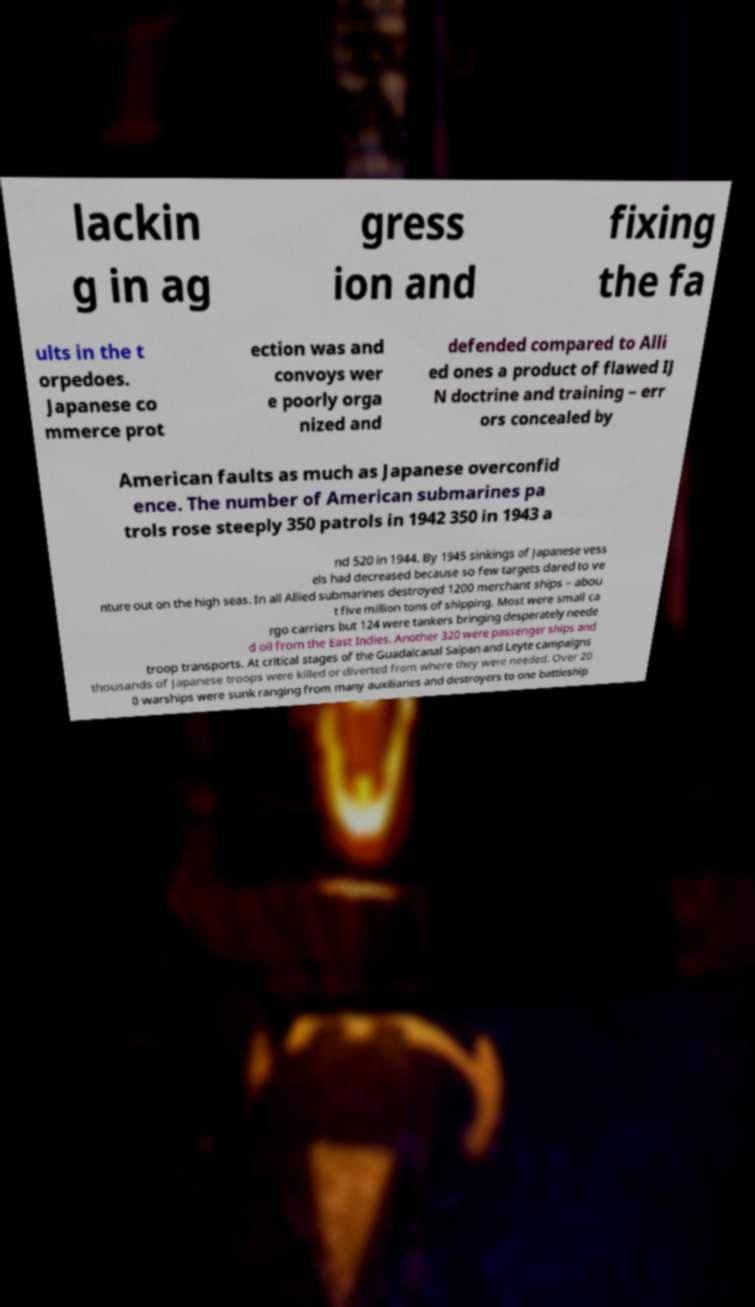Could you extract and type out the text from this image? lackin g in ag gress ion and fixing the fa ults in the t orpedoes. Japanese co mmerce prot ection was and convoys wer e poorly orga nized and defended compared to Alli ed ones a product of flawed IJ N doctrine and training – err ors concealed by American faults as much as Japanese overconfid ence. The number of American submarines pa trols rose steeply 350 patrols in 1942 350 in 1943 a nd 520 in 1944. By 1945 sinkings of Japanese vess els had decreased because so few targets dared to ve nture out on the high seas. In all Allied submarines destroyed 1200 merchant ships – abou t five million tons of shipping. Most were small ca rgo carriers but 124 were tankers bringing desperately neede d oil from the East Indies. Another 320 were passenger ships and troop transports. At critical stages of the Guadalcanal Saipan and Leyte campaigns thousands of Japanese troops were killed or diverted from where they were needed. Over 20 0 warships were sunk ranging from many auxiliaries and destroyers to one battleship 